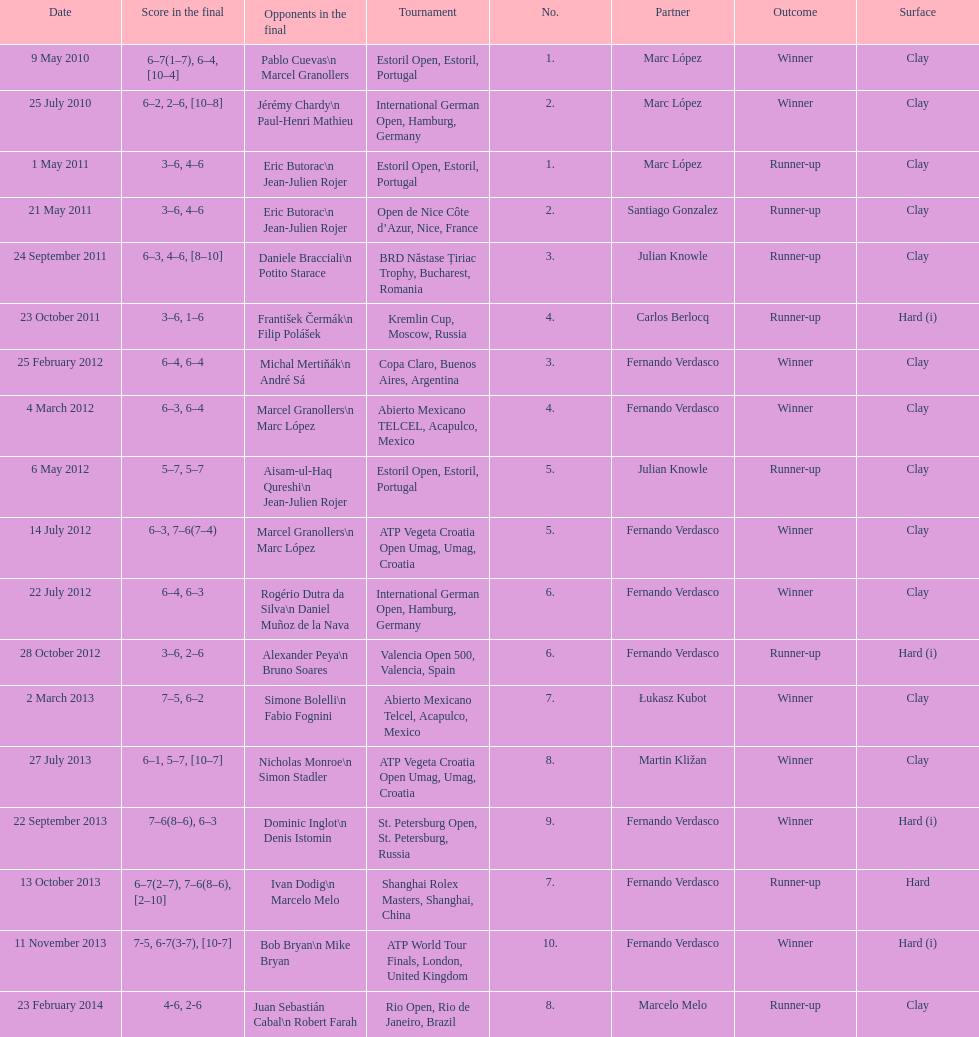Which tournament has the largest number? ATP World Tour Finals. 